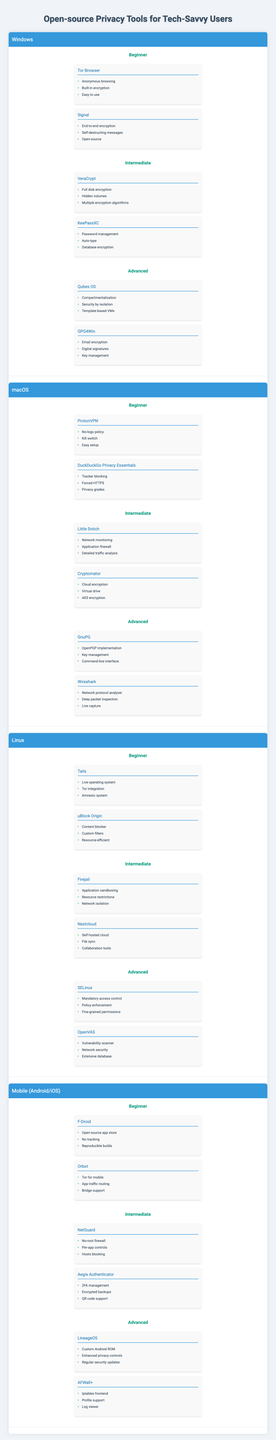What are the privacy tools available for beginners on macOS? The table lists the tools under the "Beginner" category for macOS, which are "ProtonVPN" and "DuckDuckGo Privacy Essentials."
Answer: ProtonVPN and DuckDuckGo Privacy Essentials Which tool features full disk encryption for Windows? From the intermediate level for Windows, the tool listed with full disk encryption is "VeraCrypt."
Answer: VeraCrypt How many privacy tools are categorized as advanced for Linux? The advanced category lists two tools under Linux: "SELinux" and "OpenVAS," so the count is 2.
Answer: 2 Is "Tails" available for Linux users? According to the table, "Tails" is listed under the beginner level for Linux, confirming its availability.
Answer: Yes Which operating system has more intermediate tools, Windows or macOS? Windows has "VeraCrypt" and "KeePassXC" (2 tools), while macOS has "Little Snitch" and "Cryptomator" (2 tools), making the counts equal.
Answer: Equal What are the features of the tool "LineageOS"? The advanced tool "LineageOS" features a custom Android ROM, enhanced privacy controls, and regular security updates, as detailed in the mobile section.
Answer: Custom Android ROM, enhanced privacy controls, regular security updates For mobile users, which tool provides no tracking? The beginner tool "F-Droid" for mobile users is designed as an open-source app store with a no-tracking policy.
Answer: F-Droid Which tool has features related to network security categorized as advanced under any operating system? The advanced tool "OpenVAS" listed under Linux features network security among its capabilities.
Answer: OpenVAS Are there more features listed for "GnuPG" than for "uBlock Origin"? "GnuPG" has three features: openPGP implementation, key management, and command-line interface, while "uBlock Origin" has three features as well, so they are equal.
Answer: Yes Which operating system has a built-in encryption tool for beginners? The table indicates that "Tor Browser," which includes built-in encryption, is available for Windows beginners.
Answer: Windows 